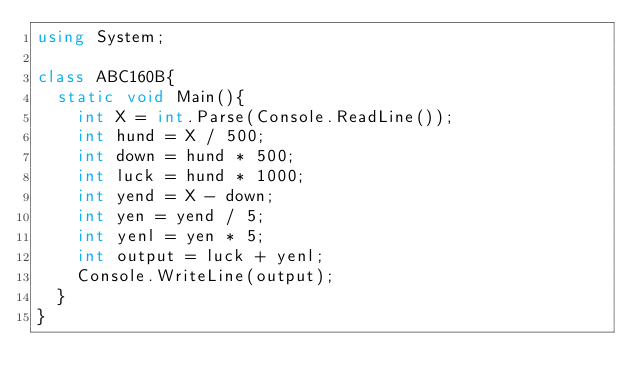Convert code to text. <code><loc_0><loc_0><loc_500><loc_500><_C#_>using System;

class ABC160B{
  static void Main(){
    int X = int.Parse(Console.ReadLine());
    int hund = X / 500;
    int down = hund * 500;
    int luck = hund * 1000;
    int yend = X - down;
    int yen = yend / 5;
    int yenl = yen * 5;
    int output = luck + yenl;
    Console.WriteLine(output);
  }
}</code> 